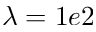Convert formula to latex. <formula><loc_0><loc_0><loc_500><loc_500>\lambda = 1 e 2</formula> 